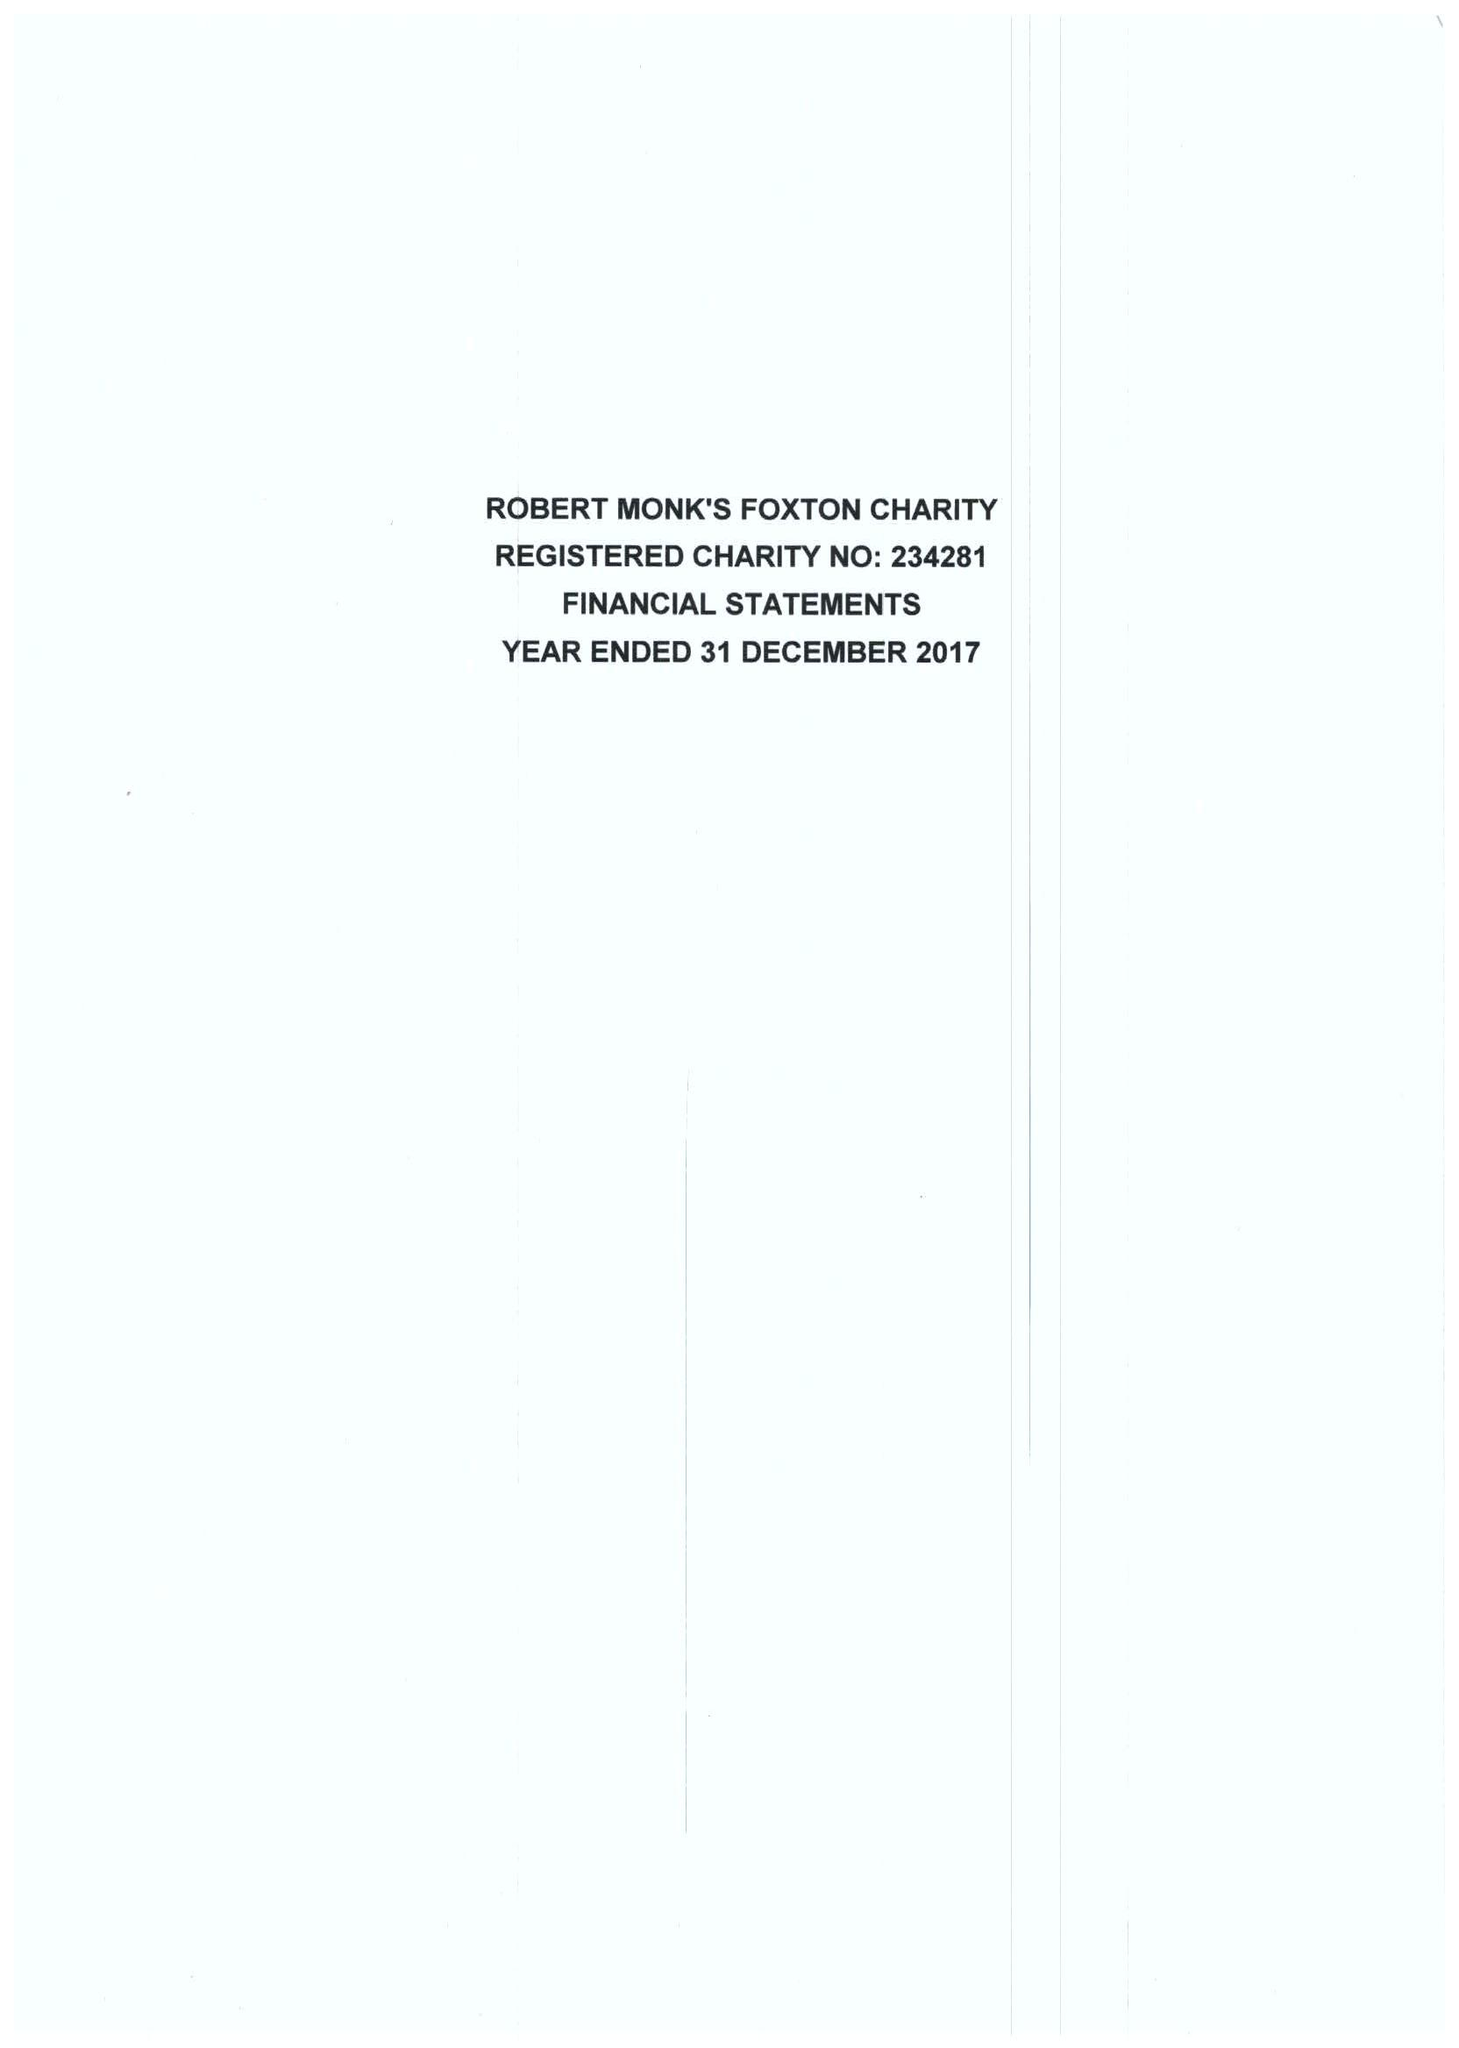What is the value for the address__street_line?
Answer the question using a single word or phrase. 49 MIDDLE STREET 